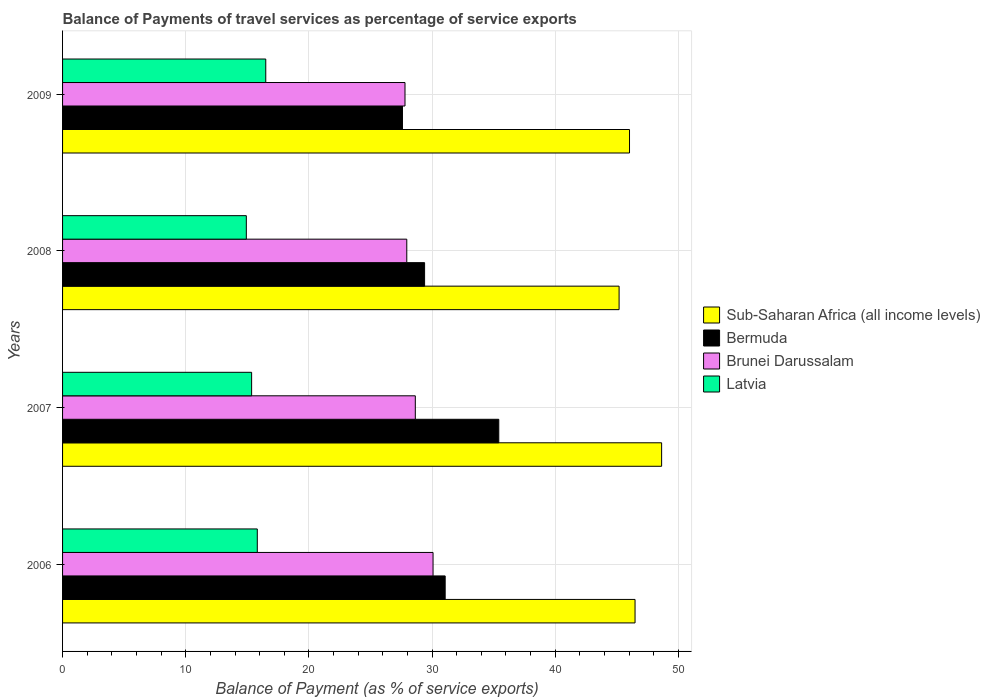How many different coloured bars are there?
Make the answer very short. 4. In how many cases, is the number of bars for a given year not equal to the number of legend labels?
Make the answer very short. 0. What is the balance of payments of travel services in Brunei Darussalam in 2009?
Offer a terse response. 27.8. Across all years, what is the maximum balance of payments of travel services in Brunei Darussalam?
Offer a very short reply. 30.08. Across all years, what is the minimum balance of payments of travel services in Brunei Darussalam?
Provide a short and direct response. 27.8. In which year was the balance of payments of travel services in Bermuda maximum?
Your answer should be compact. 2007. In which year was the balance of payments of travel services in Brunei Darussalam minimum?
Your response must be concise. 2009. What is the total balance of payments of travel services in Latvia in the graph?
Make the answer very short. 62.58. What is the difference between the balance of payments of travel services in Bermuda in 2006 and that in 2009?
Give a very brief answer. 3.47. What is the difference between the balance of payments of travel services in Bermuda in 2006 and the balance of payments of travel services in Sub-Saharan Africa (all income levels) in 2008?
Give a very brief answer. -14.12. What is the average balance of payments of travel services in Bermuda per year?
Keep it short and to the point. 30.87. In the year 2008, what is the difference between the balance of payments of travel services in Bermuda and balance of payments of travel services in Latvia?
Make the answer very short. 14.47. In how many years, is the balance of payments of travel services in Brunei Darussalam greater than 28 %?
Offer a very short reply. 2. What is the ratio of the balance of payments of travel services in Bermuda in 2008 to that in 2009?
Make the answer very short. 1.07. Is the balance of payments of travel services in Brunei Darussalam in 2006 less than that in 2009?
Provide a succinct answer. No. What is the difference between the highest and the second highest balance of payments of travel services in Sub-Saharan Africa (all income levels)?
Your response must be concise. 2.16. What is the difference between the highest and the lowest balance of payments of travel services in Brunei Darussalam?
Your answer should be very brief. 2.28. In how many years, is the balance of payments of travel services in Sub-Saharan Africa (all income levels) greater than the average balance of payments of travel services in Sub-Saharan Africa (all income levels) taken over all years?
Keep it short and to the point. 1. Is the sum of the balance of payments of travel services in Latvia in 2008 and 2009 greater than the maximum balance of payments of travel services in Bermuda across all years?
Provide a short and direct response. No. Is it the case that in every year, the sum of the balance of payments of travel services in Sub-Saharan Africa (all income levels) and balance of payments of travel services in Bermuda is greater than the sum of balance of payments of travel services in Brunei Darussalam and balance of payments of travel services in Latvia?
Your response must be concise. Yes. What does the 2nd bar from the top in 2008 represents?
Provide a succinct answer. Brunei Darussalam. What does the 3rd bar from the bottom in 2006 represents?
Your answer should be very brief. Brunei Darussalam. Is it the case that in every year, the sum of the balance of payments of travel services in Brunei Darussalam and balance of payments of travel services in Latvia is greater than the balance of payments of travel services in Sub-Saharan Africa (all income levels)?
Provide a short and direct response. No. Are all the bars in the graph horizontal?
Make the answer very short. Yes. How many years are there in the graph?
Make the answer very short. 4. What is the difference between two consecutive major ticks on the X-axis?
Your response must be concise. 10. Are the values on the major ticks of X-axis written in scientific E-notation?
Your response must be concise. No. Where does the legend appear in the graph?
Make the answer very short. Center right. What is the title of the graph?
Offer a terse response. Balance of Payments of travel services as percentage of service exports. What is the label or title of the X-axis?
Make the answer very short. Balance of Payment (as % of service exports). What is the label or title of the Y-axis?
Your answer should be very brief. Years. What is the Balance of Payment (as % of service exports) of Sub-Saharan Africa (all income levels) in 2006?
Your answer should be very brief. 46.48. What is the Balance of Payment (as % of service exports) of Bermuda in 2006?
Give a very brief answer. 31.06. What is the Balance of Payment (as % of service exports) of Brunei Darussalam in 2006?
Offer a terse response. 30.08. What is the Balance of Payment (as % of service exports) of Latvia in 2006?
Your answer should be compact. 15.81. What is the Balance of Payment (as % of service exports) of Sub-Saharan Africa (all income levels) in 2007?
Offer a terse response. 48.64. What is the Balance of Payment (as % of service exports) of Bermuda in 2007?
Ensure brevity in your answer.  35.42. What is the Balance of Payment (as % of service exports) of Brunei Darussalam in 2007?
Ensure brevity in your answer.  28.64. What is the Balance of Payment (as % of service exports) of Latvia in 2007?
Ensure brevity in your answer.  15.35. What is the Balance of Payment (as % of service exports) in Sub-Saharan Africa (all income levels) in 2008?
Give a very brief answer. 45.19. What is the Balance of Payment (as % of service exports) in Bermuda in 2008?
Your answer should be compact. 29.39. What is the Balance of Payment (as % of service exports) in Brunei Darussalam in 2008?
Keep it short and to the point. 27.95. What is the Balance of Payment (as % of service exports) in Latvia in 2008?
Provide a short and direct response. 14.92. What is the Balance of Payment (as % of service exports) of Sub-Saharan Africa (all income levels) in 2009?
Make the answer very short. 46.03. What is the Balance of Payment (as % of service exports) of Bermuda in 2009?
Provide a short and direct response. 27.6. What is the Balance of Payment (as % of service exports) in Brunei Darussalam in 2009?
Provide a succinct answer. 27.8. What is the Balance of Payment (as % of service exports) of Latvia in 2009?
Your response must be concise. 16.5. Across all years, what is the maximum Balance of Payment (as % of service exports) in Sub-Saharan Africa (all income levels)?
Give a very brief answer. 48.64. Across all years, what is the maximum Balance of Payment (as % of service exports) of Bermuda?
Offer a very short reply. 35.42. Across all years, what is the maximum Balance of Payment (as % of service exports) in Brunei Darussalam?
Your response must be concise. 30.08. Across all years, what is the maximum Balance of Payment (as % of service exports) of Latvia?
Offer a very short reply. 16.5. Across all years, what is the minimum Balance of Payment (as % of service exports) of Sub-Saharan Africa (all income levels)?
Give a very brief answer. 45.19. Across all years, what is the minimum Balance of Payment (as % of service exports) in Bermuda?
Provide a short and direct response. 27.6. Across all years, what is the minimum Balance of Payment (as % of service exports) in Brunei Darussalam?
Make the answer very short. 27.8. Across all years, what is the minimum Balance of Payment (as % of service exports) of Latvia?
Your response must be concise. 14.92. What is the total Balance of Payment (as % of service exports) of Sub-Saharan Africa (all income levels) in the graph?
Ensure brevity in your answer.  186.34. What is the total Balance of Payment (as % of service exports) in Bermuda in the graph?
Keep it short and to the point. 123.47. What is the total Balance of Payment (as % of service exports) of Brunei Darussalam in the graph?
Offer a very short reply. 114.47. What is the total Balance of Payment (as % of service exports) of Latvia in the graph?
Provide a short and direct response. 62.58. What is the difference between the Balance of Payment (as % of service exports) in Sub-Saharan Africa (all income levels) in 2006 and that in 2007?
Ensure brevity in your answer.  -2.16. What is the difference between the Balance of Payment (as % of service exports) of Bermuda in 2006 and that in 2007?
Offer a very short reply. -4.35. What is the difference between the Balance of Payment (as % of service exports) in Brunei Darussalam in 2006 and that in 2007?
Provide a succinct answer. 1.44. What is the difference between the Balance of Payment (as % of service exports) in Latvia in 2006 and that in 2007?
Your response must be concise. 0.46. What is the difference between the Balance of Payment (as % of service exports) of Sub-Saharan Africa (all income levels) in 2006 and that in 2008?
Make the answer very short. 1.3. What is the difference between the Balance of Payment (as % of service exports) in Bermuda in 2006 and that in 2008?
Make the answer very short. 1.67. What is the difference between the Balance of Payment (as % of service exports) in Brunei Darussalam in 2006 and that in 2008?
Your response must be concise. 2.13. What is the difference between the Balance of Payment (as % of service exports) in Latvia in 2006 and that in 2008?
Your answer should be very brief. 0.89. What is the difference between the Balance of Payment (as % of service exports) in Sub-Saharan Africa (all income levels) in 2006 and that in 2009?
Provide a short and direct response. 0.45. What is the difference between the Balance of Payment (as % of service exports) of Bermuda in 2006 and that in 2009?
Your answer should be very brief. 3.47. What is the difference between the Balance of Payment (as % of service exports) in Brunei Darussalam in 2006 and that in 2009?
Provide a succinct answer. 2.28. What is the difference between the Balance of Payment (as % of service exports) in Latvia in 2006 and that in 2009?
Offer a very short reply. -0.69. What is the difference between the Balance of Payment (as % of service exports) in Sub-Saharan Africa (all income levels) in 2007 and that in 2008?
Keep it short and to the point. 3.45. What is the difference between the Balance of Payment (as % of service exports) in Bermuda in 2007 and that in 2008?
Your answer should be compact. 6.02. What is the difference between the Balance of Payment (as % of service exports) in Brunei Darussalam in 2007 and that in 2008?
Your answer should be compact. 0.69. What is the difference between the Balance of Payment (as % of service exports) in Latvia in 2007 and that in 2008?
Make the answer very short. 0.43. What is the difference between the Balance of Payment (as % of service exports) of Sub-Saharan Africa (all income levels) in 2007 and that in 2009?
Keep it short and to the point. 2.61. What is the difference between the Balance of Payment (as % of service exports) of Bermuda in 2007 and that in 2009?
Offer a very short reply. 7.82. What is the difference between the Balance of Payment (as % of service exports) in Brunei Darussalam in 2007 and that in 2009?
Provide a short and direct response. 0.84. What is the difference between the Balance of Payment (as % of service exports) in Latvia in 2007 and that in 2009?
Provide a short and direct response. -1.15. What is the difference between the Balance of Payment (as % of service exports) of Sub-Saharan Africa (all income levels) in 2008 and that in 2009?
Ensure brevity in your answer.  -0.85. What is the difference between the Balance of Payment (as % of service exports) of Bermuda in 2008 and that in 2009?
Make the answer very short. 1.8. What is the difference between the Balance of Payment (as % of service exports) in Brunei Darussalam in 2008 and that in 2009?
Offer a terse response. 0.14. What is the difference between the Balance of Payment (as % of service exports) of Latvia in 2008 and that in 2009?
Keep it short and to the point. -1.58. What is the difference between the Balance of Payment (as % of service exports) in Sub-Saharan Africa (all income levels) in 2006 and the Balance of Payment (as % of service exports) in Bermuda in 2007?
Ensure brevity in your answer.  11.06. What is the difference between the Balance of Payment (as % of service exports) in Sub-Saharan Africa (all income levels) in 2006 and the Balance of Payment (as % of service exports) in Brunei Darussalam in 2007?
Give a very brief answer. 17.84. What is the difference between the Balance of Payment (as % of service exports) of Sub-Saharan Africa (all income levels) in 2006 and the Balance of Payment (as % of service exports) of Latvia in 2007?
Offer a very short reply. 31.13. What is the difference between the Balance of Payment (as % of service exports) in Bermuda in 2006 and the Balance of Payment (as % of service exports) in Brunei Darussalam in 2007?
Give a very brief answer. 2.42. What is the difference between the Balance of Payment (as % of service exports) in Bermuda in 2006 and the Balance of Payment (as % of service exports) in Latvia in 2007?
Provide a succinct answer. 15.71. What is the difference between the Balance of Payment (as % of service exports) in Brunei Darussalam in 2006 and the Balance of Payment (as % of service exports) in Latvia in 2007?
Your response must be concise. 14.73. What is the difference between the Balance of Payment (as % of service exports) of Sub-Saharan Africa (all income levels) in 2006 and the Balance of Payment (as % of service exports) of Bermuda in 2008?
Provide a succinct answer. 17.09. What is the difference between the Balance of Payment (as % of service exports) in Sub-Saharan Africa (all income levels) in 2006 and the Balance of Payment (as % of service exports) in Brunei Darussalam in 2008?
Offer a terse response. 18.53. What is the difference between the Balance of Payment (as % of service exports) of Sub-Saharan Africa (all income levels) in 2006 and the Balance of Payment (as % of service exports) of Latvia in 2008?
Your answer should be very brief. 31.56. What is the difference between the Balance of Payment (as % of service exports) of Bermuda in 2006 and the Balance of Payment (as % of service exports) of Brunei Darussalam in 2008?
Give a very brief answer. 3.12. What is the difference between the Balance of Payment (as % of service exports) of Bermuda in 2006 and the Balance of Payment (as % of service exports) of Latvia in 2008?
Keep it short and to the point. 16.14. What is the difference between the Balance of Payment (as % of service exports) of Brunei Darussalam in 2006 and the Balance of Payment (as % of service exports) of Latvia in 2008?
Your answer should be compact. 15.16. What is the difference between the Balance of Payment (as % of service exports) of Sub-Saharan Africa (all income levels) in 2006 and the Balance of Payment (as % of service exports) of Bermuda in 2009?
Make the answer very short. 18.88. What is the difference between the Balance of Payment (as % of service exports) in Sub-Saharan Africa (all income levels) in 2006 and the Balance of Payment (as % of service exports) in Brunei Darussalam in 2009?
Your answer should be compact. 18.68. What is the difference between the Balance of Payment (as % of service exports) in Sub-Saharan Africa (all income levels) in 2006 and the Balance of Payment (as % of service exports) in Latvia in 2009?
Make the answer very short. 29.98. What is the difference between the Balance of Payment (as % of service exports) of Bermuda in 2006 and the Balance of Payment (as % of service exports) of Brunei Darussalam in 2009?
Make the answer very short. 3.26. What is the difference between the Balance of Payment (as % of service exports) of Bermuda in 2006 and the Balance of Payment (as % of service exports) of Latvia in 2009?
Your answer should be very brief. 14.57. What is the difference between the Balance of Payment (as % of service exports) of Brunei Darussalam in 2006 and the Balance of Payment (as % of service exports) of Latvia in 2009?
Your answer should be compact. 13.58. What is the difference between the Balance of Payment (as % of service exports) of Sub-Saharan Africa (all income levels) in 2007 and the Balance of Payment (as % of service exports) of Bermuda in 2008?
Offer a very short reply. 19.24. What is the difference between the Balance of Payment (as % of service exports) of Sub-Saharan Africa (all income levels) in 2007 and the Balance of Payment (as % of service exports) of Brunei Darussalam in 2008?
Your answer should be compact. 20.69. What is the difference between the Balance of Payment (as % of service exports) in Sub-Saharan Africa (all income levels) in 2007 and the Balance of Payment (as % of service exports) in Latvia in 2008?
Provide a succinct answer. 33.72. What is the difference between the Balance of Payment (as % of service exports) in Bermuda in 2007 and the Balance of Payment (as % of service exports) in Brunei Darussalam in 2008?
Provide a succinct answer. 7.47. What is the difference between the Balance of Payment (as % of service exports) of Bermuda in 2007 and the Balance of Payment (as % of service exports) of Latvia in 2008?
Offer a terse response. 20.5. What is the difference between the Balance of Payment (as % of service exports) of Brunei Darussalam in 2007 and the Balance of Payment (as % of service exports) of Latvia in 2008?
Ensure brevity in your answer.  13.72. What is the difference between the Balance of Payment (as % of service exports) of Sub-Saharan Africa (all income levels) in 2007 and the Balance of Payment (as % of service exports) of Bermuda in 2009?
Your answer should be very brief. 21.04. What is the difference between the Balance of Payment (as % of service exports) in Sub-Saharan Africa (all income levels) in 2007 and the Balance of Payment (as % of service exports) in Brunei Darussalam in 2009?
Offer a very short reply. 20.83. What is the difference between the Balance of Payment (as % of service exports) in Sub-Saharan Africa (all income levels) in 2007 and the Balance of Payment (as % of service exports) in Latvia in 2009?
Provide a short and direct response. 32.14. What is the difference between the Balance of Payment (as % of service exports) of Bermuda in 2007 and the Balance of Payment (as % of service exports) of Brunei Darussalam in 2009?
Your answer should be compact. 7.61. What is the difference between the Balance of Payment (as % of service exports) in Bermuda in 2007 and the Balance of Payment (as % of service exports) in Latvia in 2009?
Keep it short and to the point. 18.92. What is the difference between the Balance of Payment (as % of service exports) of Brunei Darussalam in 2007 and the Balance of Payment (as % of service exports) of Latvia in 2009?
Offer a terse response. 12.14. What is the difference between the Balance of Payment (as % of service exports) in Sub-Saharan Africa (all income levels) in 2008 and the Balance of Payment (as % of service exports) in Bermuda in 2009?
Ensure brevity in your answer.  17.59. What is the difference between the Balance of Payment (as % of service exports) of Sub-Saharan Africa (all income levels) in 2008 and the Balance of Payment (as % of service exports) of Brunei Darussalam in 2009?
Keep it short and to the point. 17.38. What is the difference between the Balance of Payment (as % of service exports) in Sub-Saharan Africa (all income levels) in 2008 and the Balance of Payment (as % of service exports) in Latvia in 2009?
Offer a very short reply. 28.69. What is the difference between the Balance of Payment (as % of service exports) in Bermuda in 2008 and the Balance of Payment (as % of service exports) in Brunei Darussalam in 2009?
Your answer should be very brief. 1.59. What is the difference between the Balance of Payment (as % of service exports) in Bermuda in 2008 and the Balance of Payment (as % of service exports) in Latvia in 2009?
Offer a terse response. 12.9. What is the difference between the Balance of Payment (as % of service exports) of Brunei Darussalam in 2008 and the Balance of Payment (as % of service exports) of Latvia in 2009?
Keep it short and to the point. 11.45. What is the average Balance of Payment (as % of service exports) of Sub-Saharan Africa (all income levels) per year?
Provide a short and direct response. 46.58. What is the average Balance of Payment (as % of service exports) of Bermuda per year?
Give a very brief answer. 30.87. What is the average Balance of Payment (as % of service exports) in Brunei Darussalam per year?
Ensure brevity in your answer.  28.62. What is the average Balance of Payment (as % of service exports) in Latvia per year?
Your response must be concise. 15.64. In the year 2006, what is the difference between the Balance of Payment (as % of service exports) of Sub-Saharan Africa (all income levels) and Balance of Payment (as % of service exports) of Bermuda?
Your answer should be very brief. 15.42. In the year 2006, what is the difference between the Balance of Payment (as % of service exports) in Sub-Saharan Africa (all income levels) and Balance of Payment (as % of service exports) in Brunei Darussalam?
Provide a short and direct response. 16.4. In the year 2006, what is the difference between the Balance of Payment (as % of service exports) of Sub-Saharan Africa (all income levels) and Balance of Payment (as % of service exports) of Latvia?
Give a very brief answer. 30.67. In the year 2006, what is the difference between the Balance of Payment (as % of service exports) in Bermuda and Balance of Payment (as % of service exports) in Brunei Darussalam?
Keep it short and to the point. 0.98. In the year 2006, what is the difference between the Balance of Payment (as % of service exports) of Bermuda and Balance of Payment (as % of service exports) of Latvia?
Provide a short and direct response. 15.25. In the year 2006, what is the difference between the Balance of Payment (as % of service exports) of Brunei Darussalam and Balance of Payment (as % of service exports) of Latvia?
Provide a succinct answer. 14.27. In the year 2007, what is the difference between the Balance of Payment (as % of service exports) in Sub-Saharan Africa (all income levels) and Balance of Payment (as % of service exports) in Bermuda?
Your answer should be compact. 13.22. In the year 2007, what is the difference between the Balance of Payment (as % of service exports) of Sub-Saharan Africa (all income levels) and Balance of Payment (as % of service exports) of Brunei Darussalam?
Your answer should be very brief. 20. In the year 2007, what is the difference between the Balance of Payment (as % of service exports) of Sub-Saharan Africa (all income levels) and Balance of Payment (as % of service exports) of Latvia?
Ensure brevity in your answer.  33.29. In the year 2007, what is the difference between the Balance of Payment (as % of service exports) of Bermuda and Balance of Payment (as % of service exports) of Brunei Darussalam?
Provide a succinct answer. 6.78. In the year 2007, what is the difference between the Balance of Payment (as % of service exports) in Bermuda and Balance of Payment (as % of service exports) in Latvia?
Make the answer very short. 20.07. In the year 2007, what is the difference between the Balance of Payment (as % of service exports) of Brunei Darussalam and Balance of Payment (as % of service exports) of Latvia?
Make the answer very short. 13.29. In the year 2008, what is the difference between the Balance of Payment (as % of service exports) of Sub-Saharan Africa (all income levels) and Balance of Payment (as % of service exports) of Bermuda?
Offer a very short reply. 15.79. In the year 2008, what is the difference between the Balance of Payment (as % of service exports) in Sub-Saharan Africa (all income levels) and Balance of Payment (as % of service exports) in Brunei Darussalam?
Keep it short and to the point. 17.24. In the year 2008, what is the difference between the Balance of Payment (as % of service exports) of Sub-Saharan Africa (all income levels) and Balance of Payment (as % of service exports) of Latvia?
Ensure brevity in your answer.  30.27. In the year 2008, what is the difference between the Balance of Payment (as % of service exports) of Bermuda and Balance of Payment (as % of service exports) of Brunei Darussalam?
Keep it short and to the point. 1.45. In the year 2008, what is the difference between the Balance of Payment (as % of service exports) of Bermuda and Balance of Payment (as % of service exports) of Latvia?
Give a very brief answer. 14.47. In the year 2008, what is the difference between the Balance of Payment (as % of service exports) in Brunei Darussalam and Balance of Payment (as % of service exports) in Latvia?
Ensure brevity in your answer.  13.03. In the year 2009, what is the difference between the Balance of Payment (as % of service exports) of Sub-Saharan Africa (all income levels) and Balance of Payment (as % of service exports) of Bermuda?
Ensure brevity in your answer.  18.43. In the year 2009, what is the difference between the Balance of Payment (as % of service exports) of Sub-Saharan Africa (all income levels) and Balance of Payment (as % of service exports) of Brunei Darussalam?
Offer a very short reply. 18.23. In the year 2009, what is the difference between the Balance of Payment (as % of service exports) in Sub-Saharan Africa (all income levels) and Balance of Payment (as % of service exports) in Latvia?
Give a very brief answer. 29.53. In the year 2009, what is the difference between the Balance of Payment (as % of service exports) of Bermuda and Balance of Payment (as % of service exports) of Brunei Darussalam?
Your answer should be very brief. -0.21. In the year 2009, what is the difference between the Balance of Payment (as % of service exports) of Bermuda and Balance of Payment (as % of service exports) of Latvia?
Offer a terse response. 11.1. In the year 2009, what is the difference between the Balance of Payment (as % of service exports) in Brunei Darussalam and Balance of Payment (as % of service exports) in Latvia?
Ensure brevity in your answer.  11.3. What is the ratio of the Balance of Payment (as % of service exports) of Sub-Saharan Africa (all income levels) in 2006 to that in 2007?
Offer a very short reply. 0.96. What is the ratio of the Balance of Payment (as % of service exports) of Bermuda in 2006 to that in 2007?
Offer a terse response. 0.88. What is the ratio of the Balance of Payment (as % of service exports) of Brunei Darussalam in 2006 to that in 2007?
Ensure brevity in your answer.  1.05. What is the ratio of the Balance of Payment (as % of service exports) of Sub-Saharan Africa (all income levels) in 2006 to that in 2008?
Keep it short and to the point. 1.03. What is the ratio of the Balance of Payment (as % of service exports) of Bermuda in 2006 to that in 2008?
Your answer should be very brief. 1.06. What is the ratio of the Balance of Payment (as % of service exports) of Brunei Darussalam in 2006 to that in 2008?
Keep it short and to the point. 1.08. What is the ratio of the Balance of Payment (as % of service exports) of Latvia in 2006 to that in 2008?
Offer a terse response. 1.06. What is the ratio of the Balance of Payment (as % of service exports) of Sub-Saharan Africa (all income levels) in 2006 to that in 2009?
Your answer should be compact. 1.01. What is the ratio of the Balance of Payment (as % of service exports) of Bermuda in 2006 to that in 2009?
Offer a very short reply. 1.13. What is the ratio of the Balance of Payment (as % of service exports) of Brunei Darussalam in 2006 to that in 2009?
Your response must be concise. 1.08. What is the ratio of the Balance of Payment (as % of service exports) of Latvia in 2006 to that in 2009?
Your answer should be compact. 0.96. What is the ratio of the Balance of Payment (as % of service exports) in Sub-Saharan Africa (all income levels) in 2007 to that in 2008?
Your answer should be compact. 1.08. What is the ratio of the Balance of Payment (as % of service exports) in Bermuda in 2007 to that in 2008?
Make the answer very short. 1.2. What is the ratio of the Balance of Payment (as % of service exports) in Brunei Darussalam in 2007 to that in 2008?
Keep it short and to the point. 1.02. What is the ratio of the Balance of Payment (as % of service exports) of Latvia in 2007 to that in 2008?
Ensure brevity in your answer.  1.03. What is the ratio of the Balance of Payment (as % of service exports) in Sub-Saharan Africa (all income levels) in 2007 to that in 2009?
Provide a short and direct response. 1.06. What is the ratio of the Balance of Payment (as % of service exports) in Bermuda in 2007 to that in 2009?
Keep it short and to the point. 1.28. What is the ratio of the Balance of Payment (as % of service exports) in Brunei Darussalam in 2007 to that in 2009?
Offer a terse response. 1.03. What is the ratio of the Balance of Payment (as % of service exports) of Latvia in 2007 to that in 2009?
Provide a short and direct response. 0.93. What is the ratio of the Balance of Payment (as % of service exports) in Sub-Saharan Africa (all income levels) in 2008 to that in 2009?
Provide a short and direct response. 0.98. What is the ratio of the Balance of Payment (as % of service exports) of Bermuda in 2008 to that in 2009?
Make the answer very short. 1.07. What is the ratio of the Balance of Payment (as % of service exports) of Latvia in 2008 to that in 2009?
Offer a terse response. 0.9. What is the difference between the highest and the second highest Balance of Payment (as % of service exports) in Sub-Saharan Africa (all income levels)?
Your answer should be very brief. 2.16. What is the difference between the highest and the second highest Balance of Payment (as % of service exports) of Bermuda?
Give a very brief answer. 4.35. What is the difference between the highest and the second highest Balance of Payment (as % of service exports) in Brunei Darussalam?
Give a very brief answer. 1.44. What is the difference between the highest and the second highest Balance of Payment (as % of service exports) in Latvia?
Ensure brevity in your answer.  0.69. What is the difference between the highest and the lowest Balance of Payment (as % of service exports) of Sub-Saharan Africa (all income levels)?
Offer a terse response. 3.45. What is the difference between the highest and the lowest Balance of Payment (as % of service exports) in Bermuda?
Provide a succinct answer. 7.82. What is the difference between the highest and the lowest Balance of Payment (as % of service exports) in Brunei Darussalam?
Your answer should be compact. 2.28. What is the difference between the highest and the lowest Balance of Payment (as % of service exports) in Latvia?
Provide a succinct answer. 1.58. 